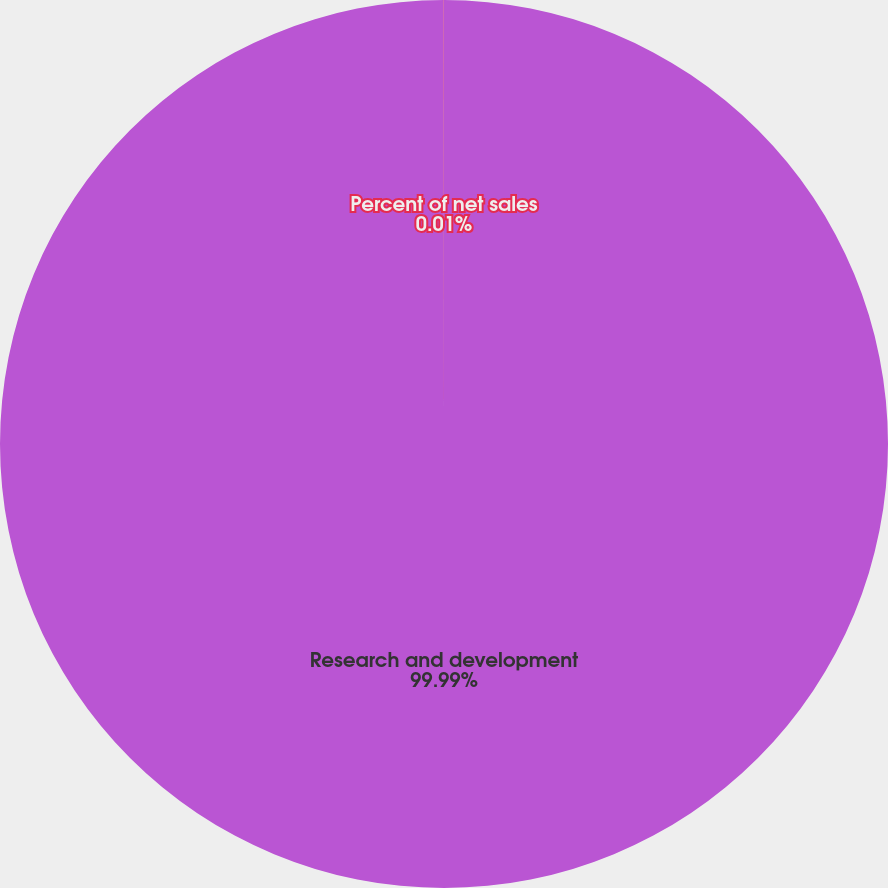<chart> <loc_0><loc_0><loc_500><loc_500><pie_chart><fcel>Research and development<fcel>Percent of net sales<nl><fcel>99.99%<fcel>0.01%<nl></chart> 